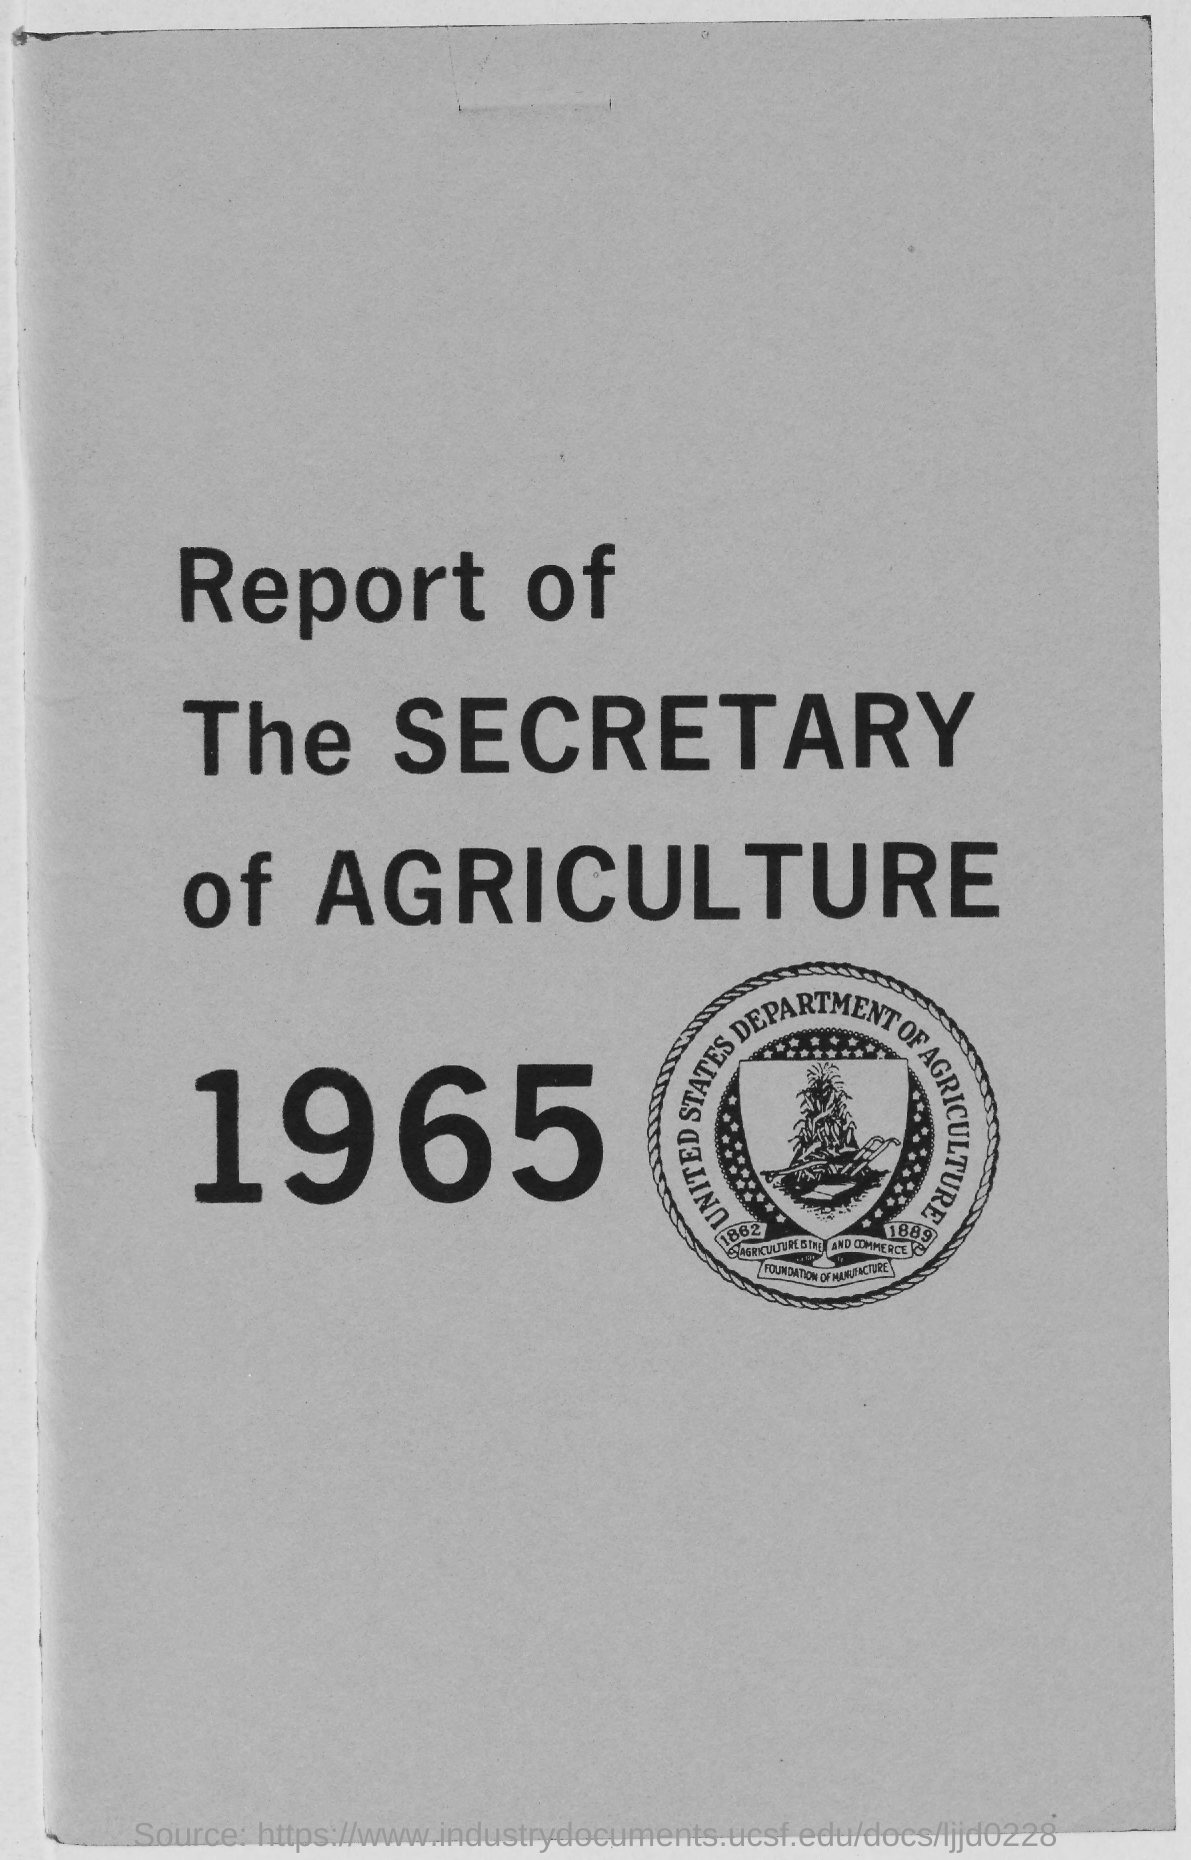Specify some key components in this picture. The Secretary of Agriculture's report of 1965 is given here. 